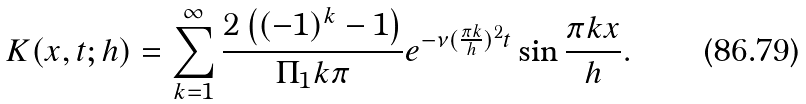Convert formula to latex. <formula><loc_0><loc_0><loc_500><loc_500>K ( x , t ; h ) = \sum _ { k = 1 } ^ { \infty } \frac { 2 \left ( ( - 1 ) ^ { k } - 1 \right ) } { \Pi _ { 1 } k \pi } e ^ { - \nu ( \frac { \pi k } { h } ) ^ { 2 } t } \sin \frac { \pi k x } { h } .</formula> 